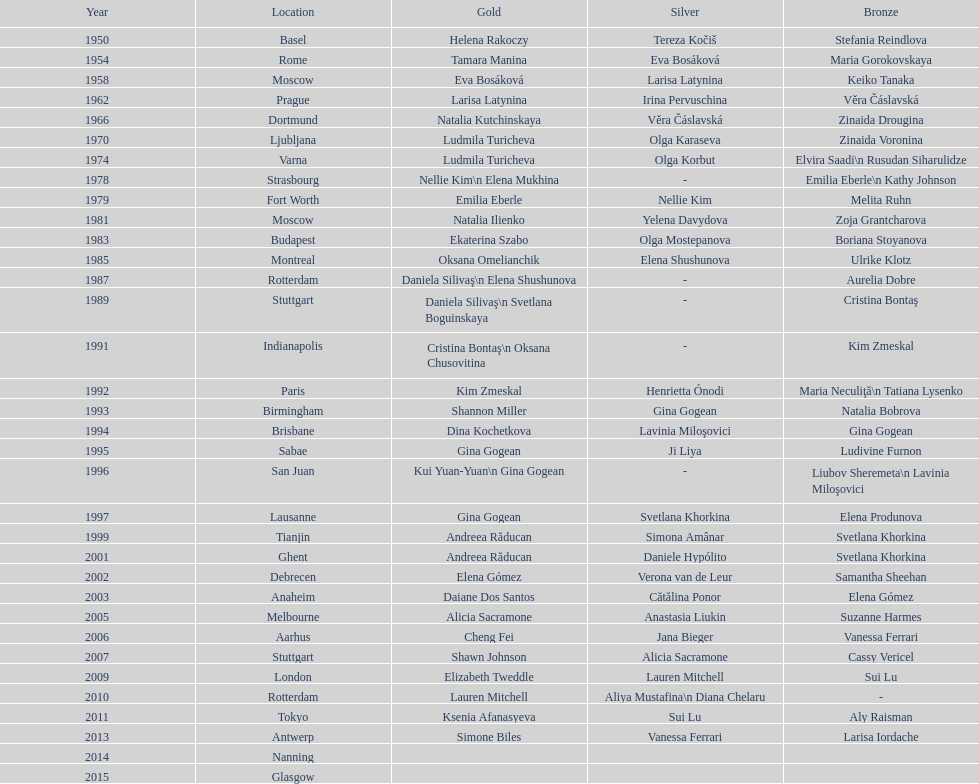In which location were the championships held before taking place in prague in 1962? Moscow. 